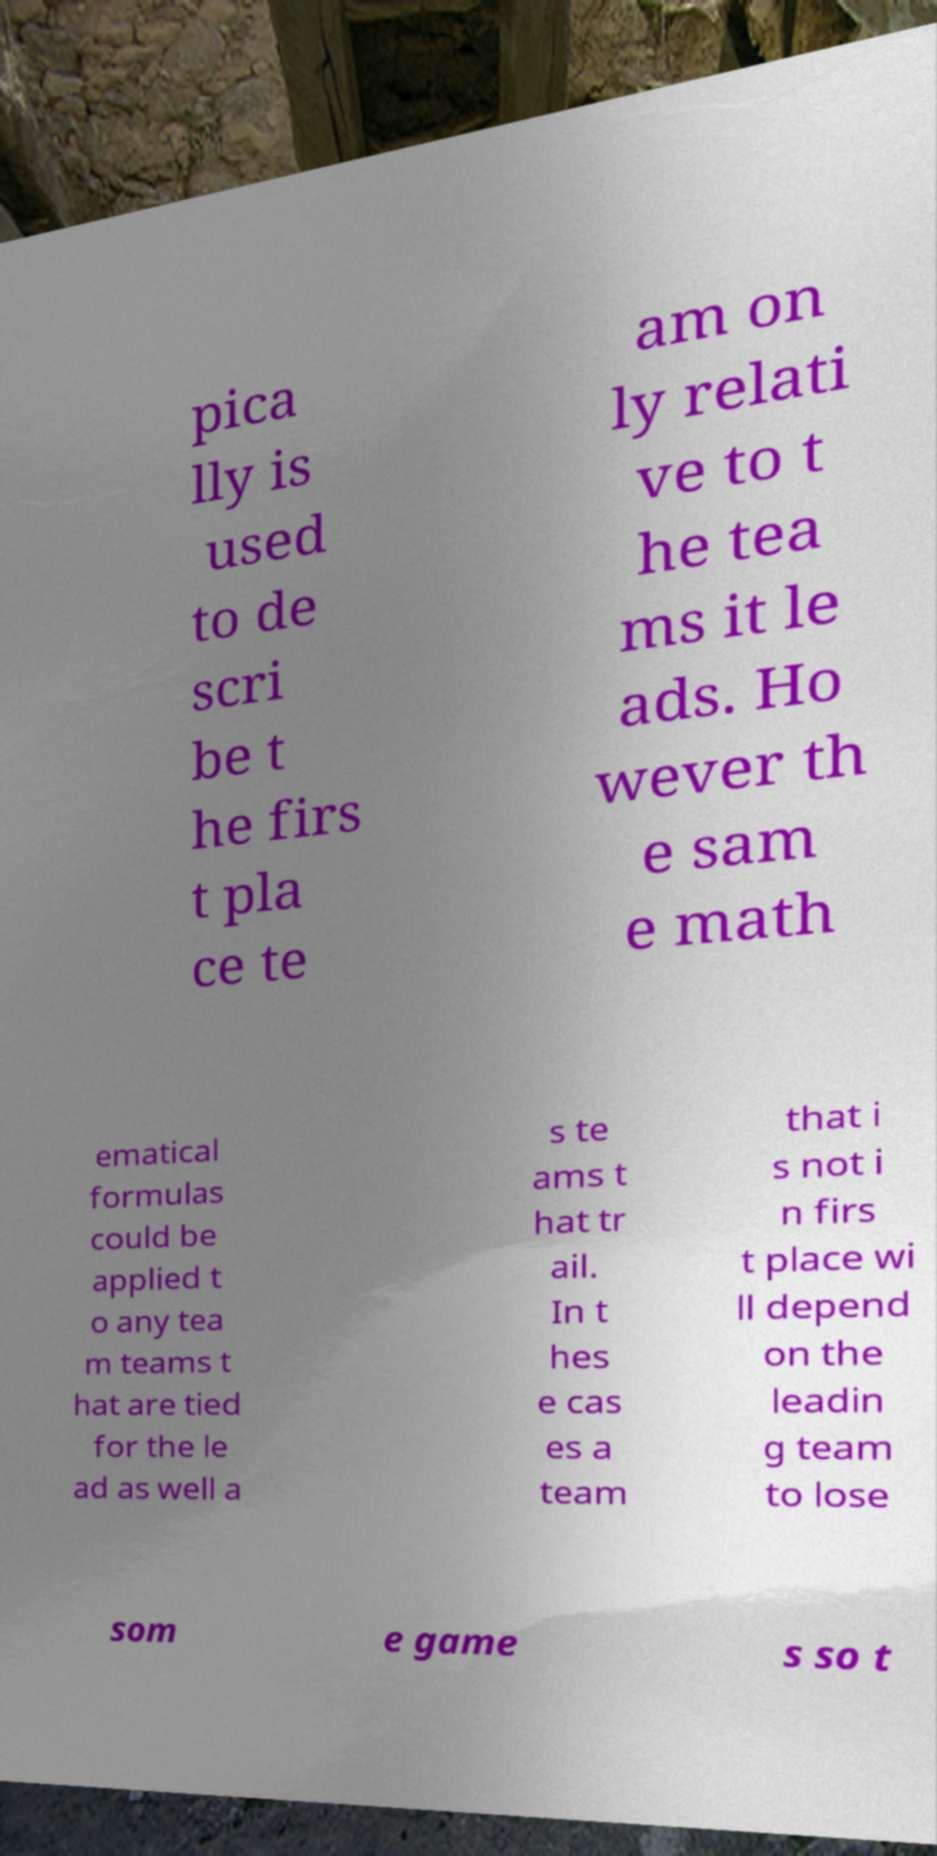There's text embedded in this image that I need extracted. Can you transcribe it verbatim? pica lly is used to de scri be t he firs t pla ce te am on ly relati ve to t he tea ms it le ads. Ho wever th e sam e math ematical formulas could be applied t o any tea m teams t hat are tied for the le ad as well a s te ams t hat tr ail. In t hes e cas es a team that i s not i n firs t place wi ll depend on the leadin g team to lose som e game s so t 